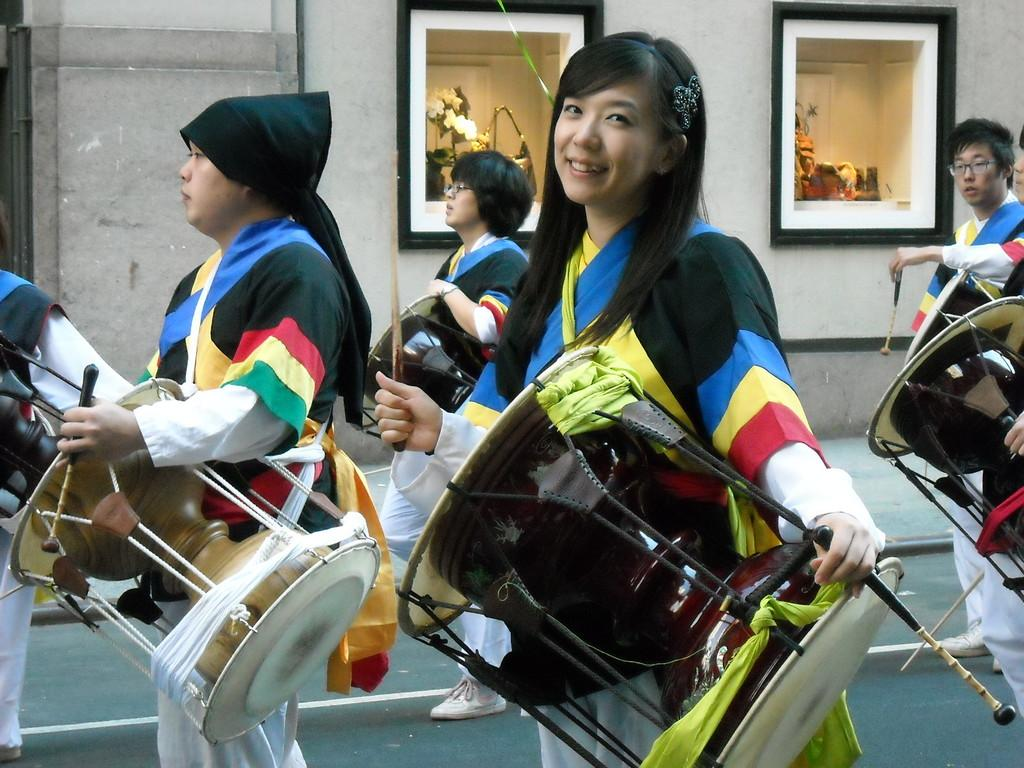How many people are in the image? There are multiple people in the image. What are the people in the image doing? The people are standing. What are the people holding in the image? The people are holding musical instruments. What type of arch can be seen in the image? There is no arch present in the image. What type of fork is being used by the people in the image? There is no fork present in the image; the people are holding musical instruments. 